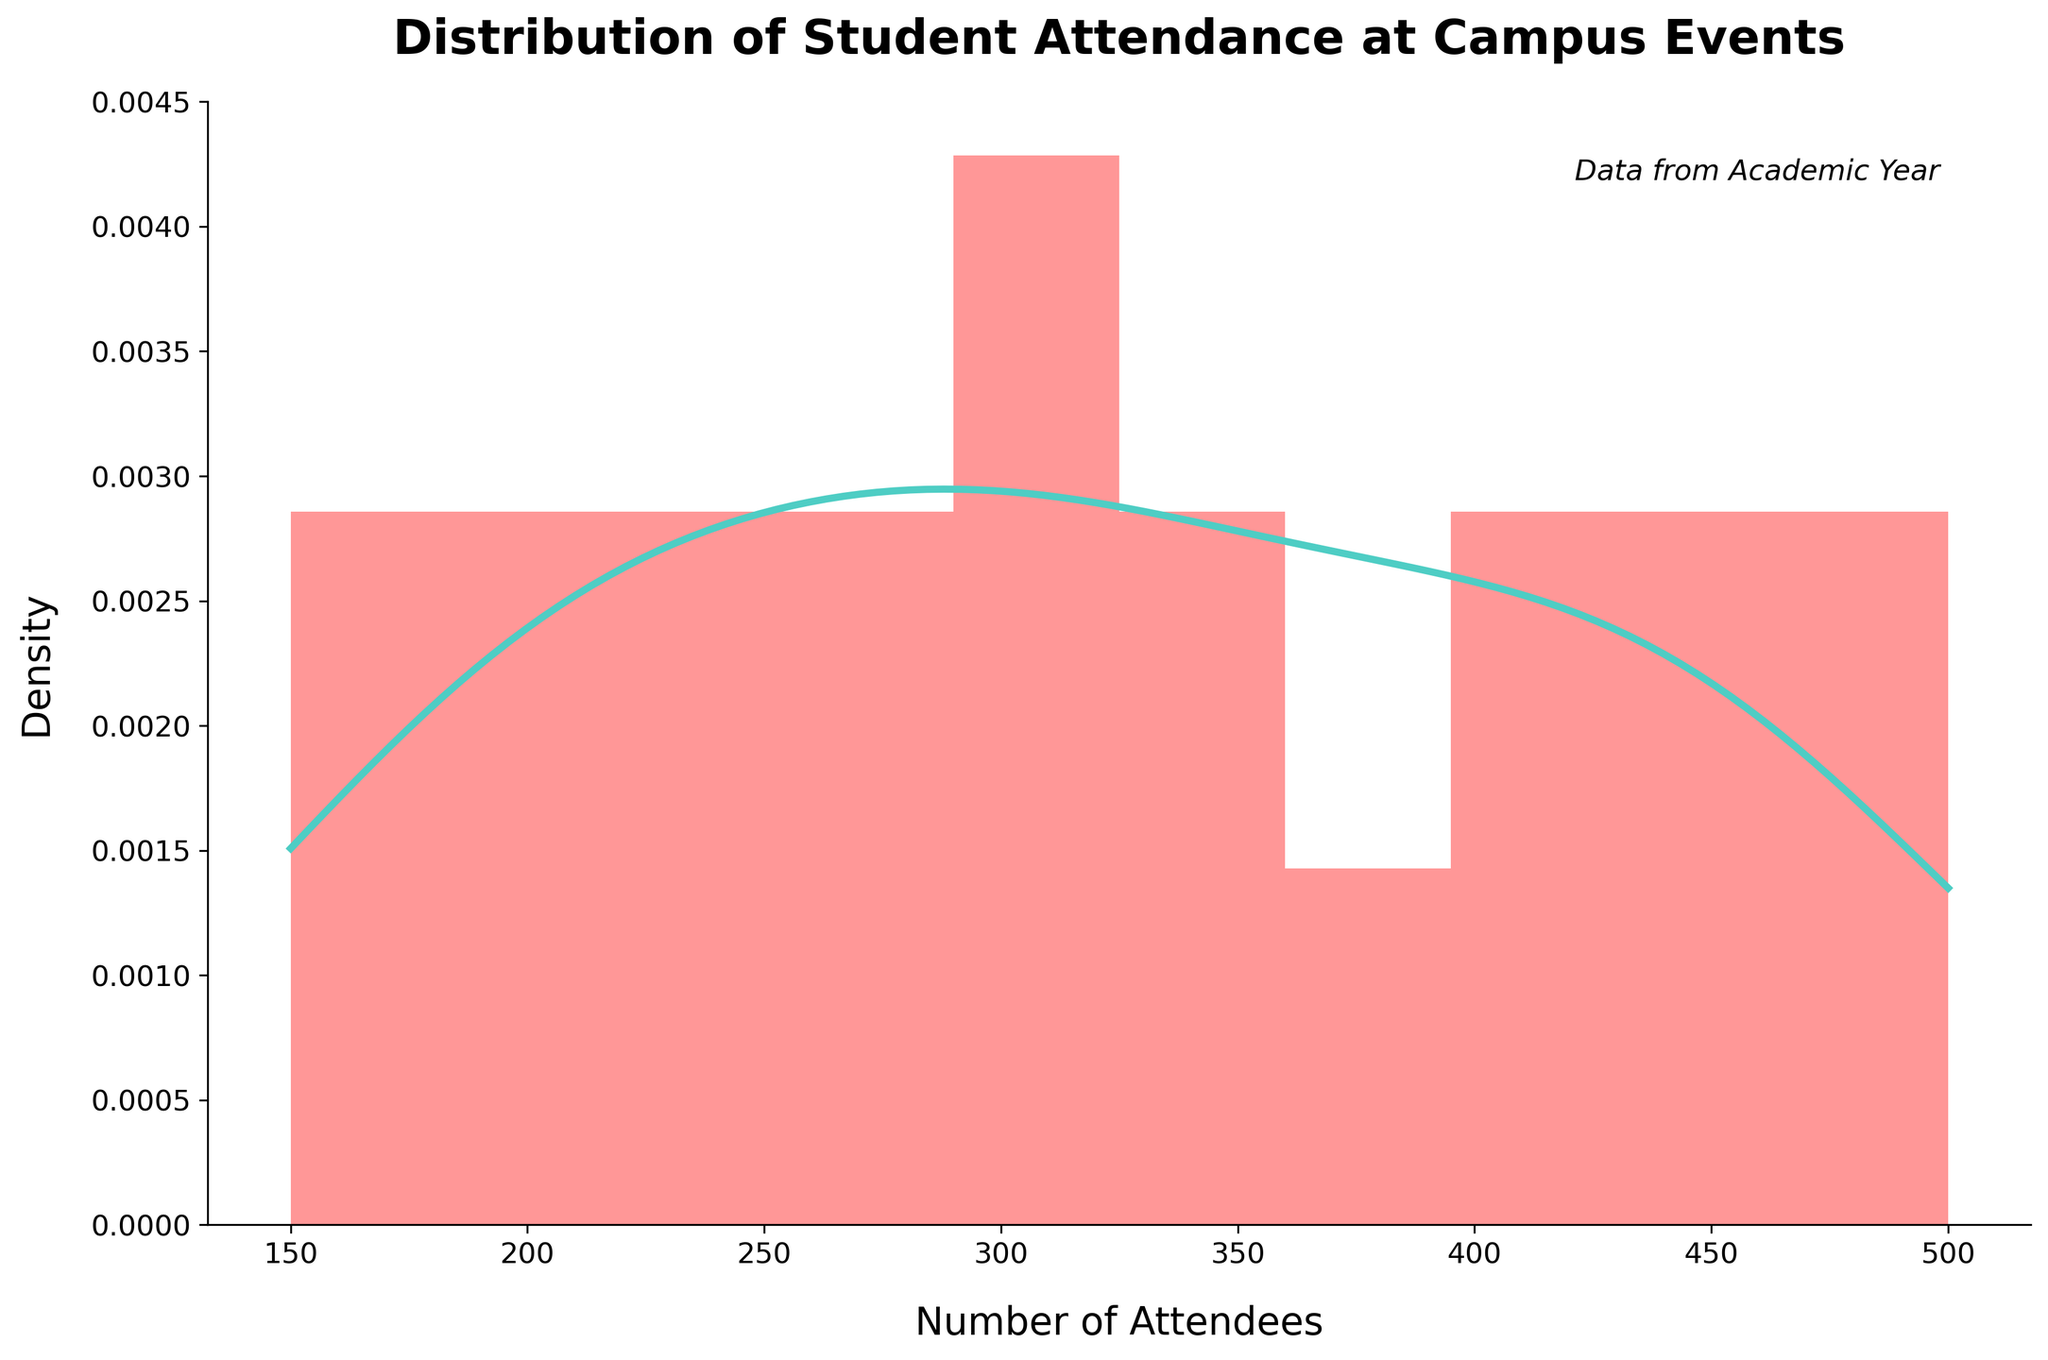What does the title of the figure say? The title is the text present at the top of the figure and often describes the content or purpose of the chart.
Answer: Distribution of Student Attendance at Campus Events What are the labels on the x-axis and y-axis? The x-axis label is found at the bottom horizontal edge of the plot, and the y-axis label is on the left vertical edge of the plot.
Answer: Number of Attendees (x-axis), Density (y-axis) Which event had the highest attendance? To determine the highest attendance, check the rightmost edge of the histogram and also confirm whether it corresponds to the peak in the KDE curve. The event which reaches the farthest to the right is Graduation Celebration with 500 attendees.
Answer: Graduation Celebration What is the approximate range of attendance values depicted in the histogram? The range is determined by identifying the minimum and maximum attendance values on the x-axis. The KDE curve on the histogram helps verify that the attendance values span from just below 200 to slightly above 500.
Answer: 150-500 How many bins are used in the histogram? Count the number of bars in the histogram, each representing a bin. The colors might help differentiate them.
Answer: 10 What does the KDE curve represent in the context of this histogram? The KDE curve is a smooth line that represents the estimated probability density function of the attendance data. It helps visualize the data distribution trend without the binning process of the histogram.
Answer: Estimated density function Does the KDE suggest that the attendance distribution is skewed, and if so, which direction? To determine the skewness, observe the shape of the KDE curve. If it has a longer tail on one side, it indicates skewness in that direction. The KDE shows slightly more weight on the right side, suggesting a right skew.
Answer: Right skew Which attendance interval has the highest number of events? Identify the interval with the tallest histogram bar. The interval with the most bars visually represents the highest number of events. The bin from about 300 to 350 attendees appears to have the highest bar.
Answer: 300-350 attendees Is the attendance distribution mostly concentrated within a certain range? Look at where the majority of the bars and the KDE peak are located. The attendance values are more concentrated around the range of 250 to 450 attendees, seeing the majority of histogram bars and the KDE peak within this interval.
Answer: 250-450 attendees 